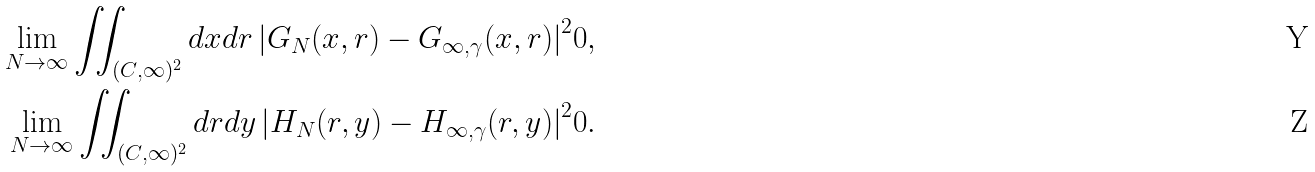<formula> <loc_0><loc_0><loc_500><loc_500>\lim _ { N \to \infty } \iint _ { ( C , \infty ) ^ { 2 } } d x d r \left | G _ { N } ( x , r ) - G _ { \infty , \gamma } ( x , r ) \right | ^ { 2 } & 0 , \\ \lim _ { N \to \infty } \iint _ { ( C , \infty ) ^ { 2 } } d r d y \left | H _ { N } ( r , y ) - H _ { \infty , \gamma } ( r , y ) \right | ^ { 2 } & 0 .</formula> 